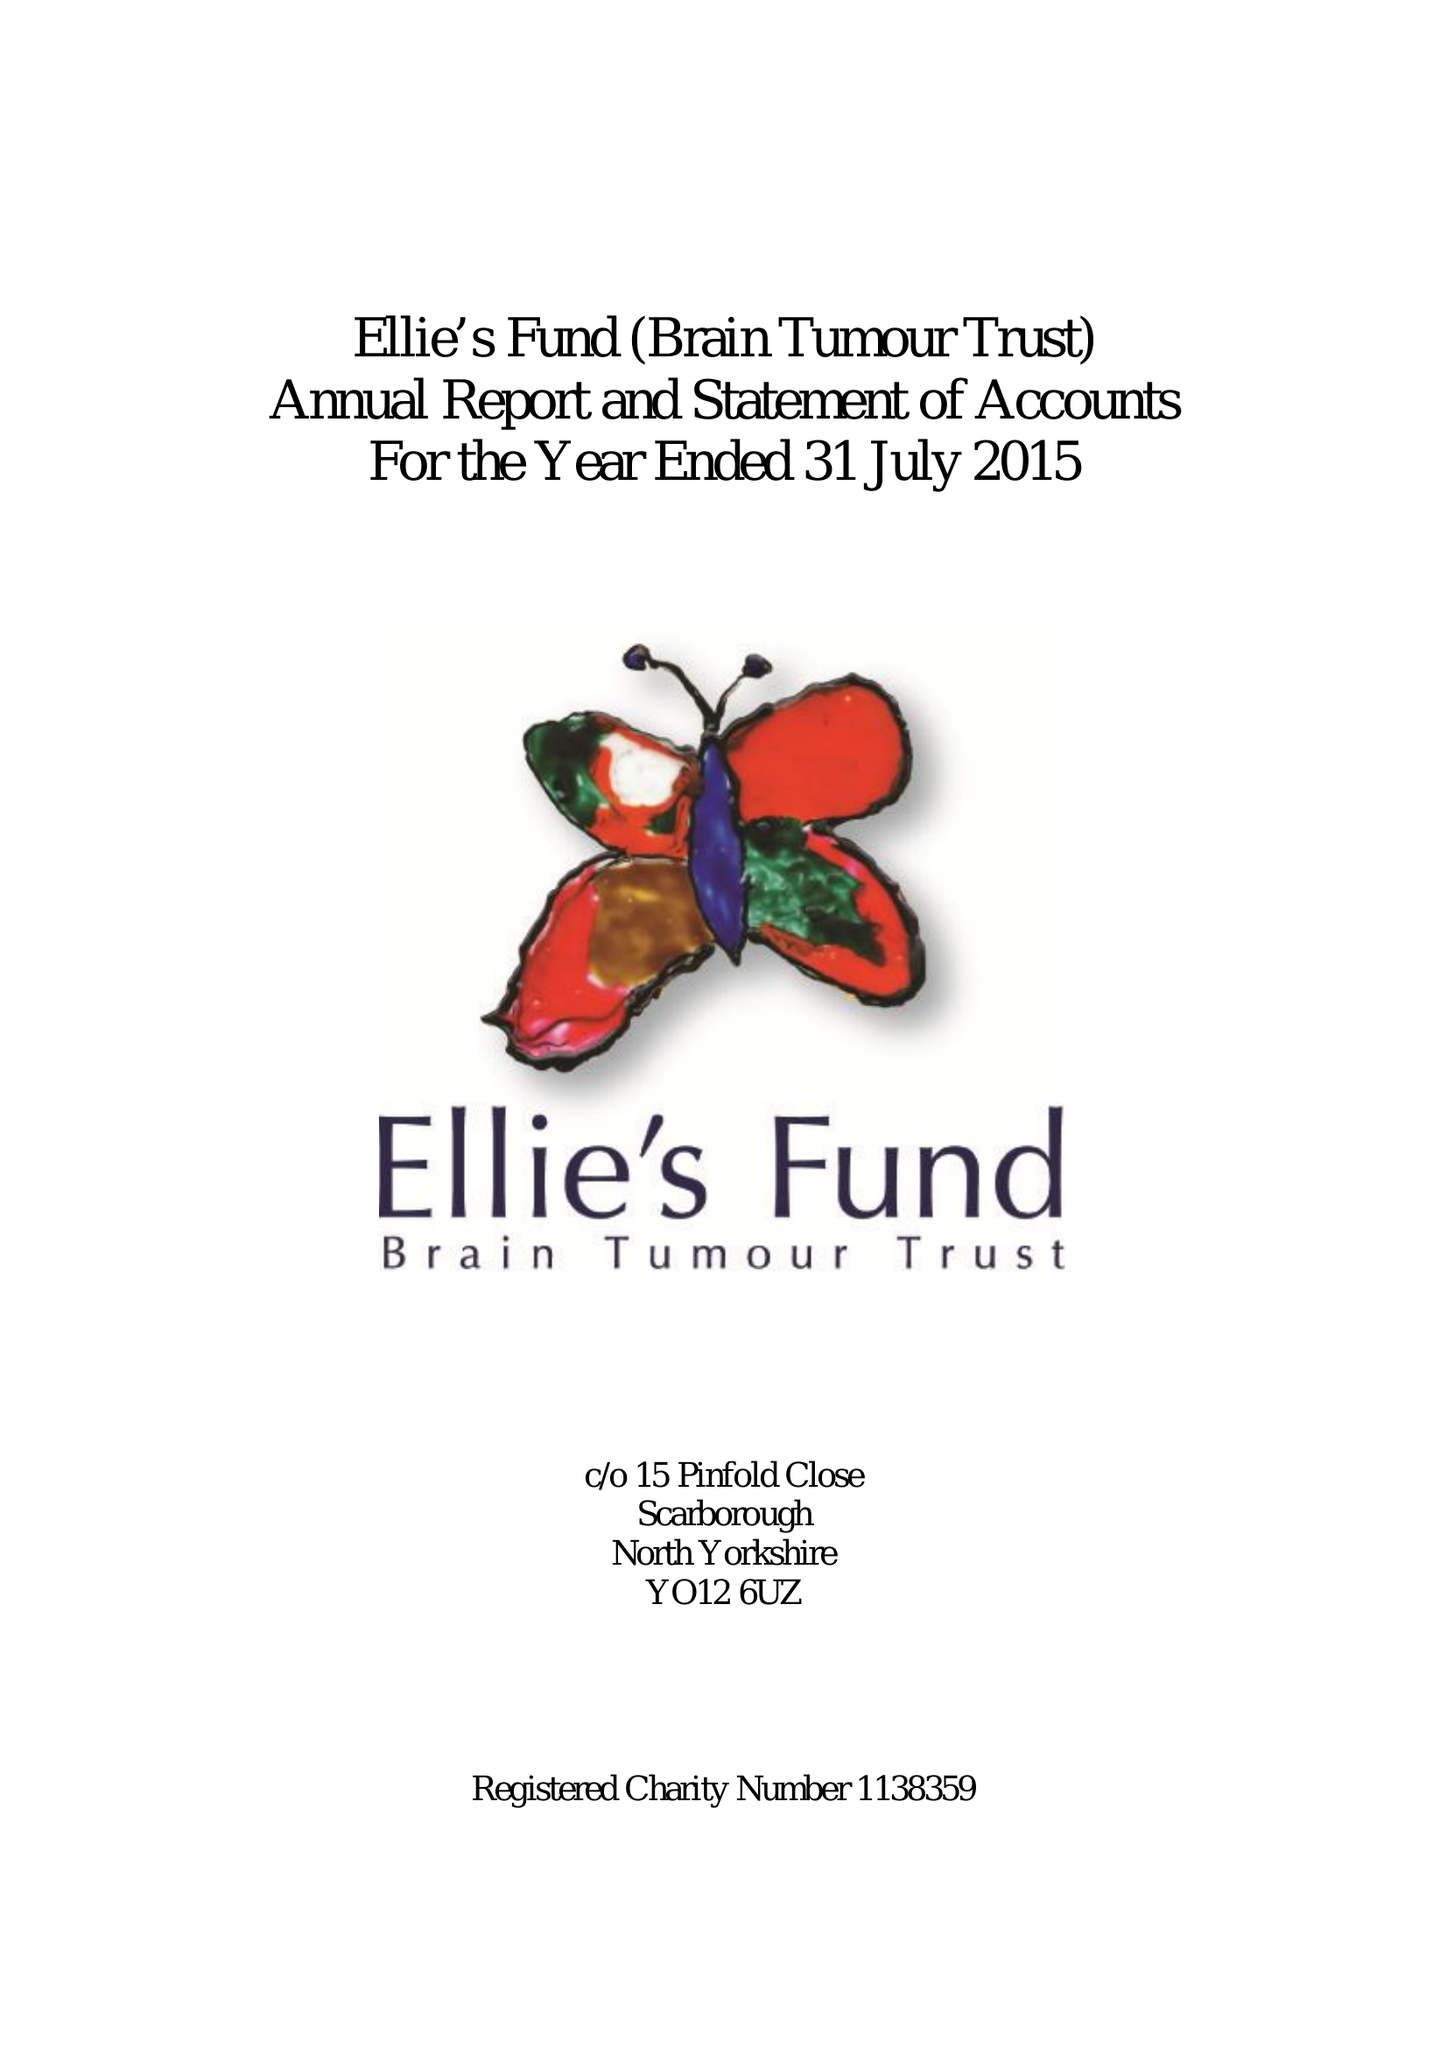What is the value for the address__postcode?
Answer the question using a single word or phrase. None 